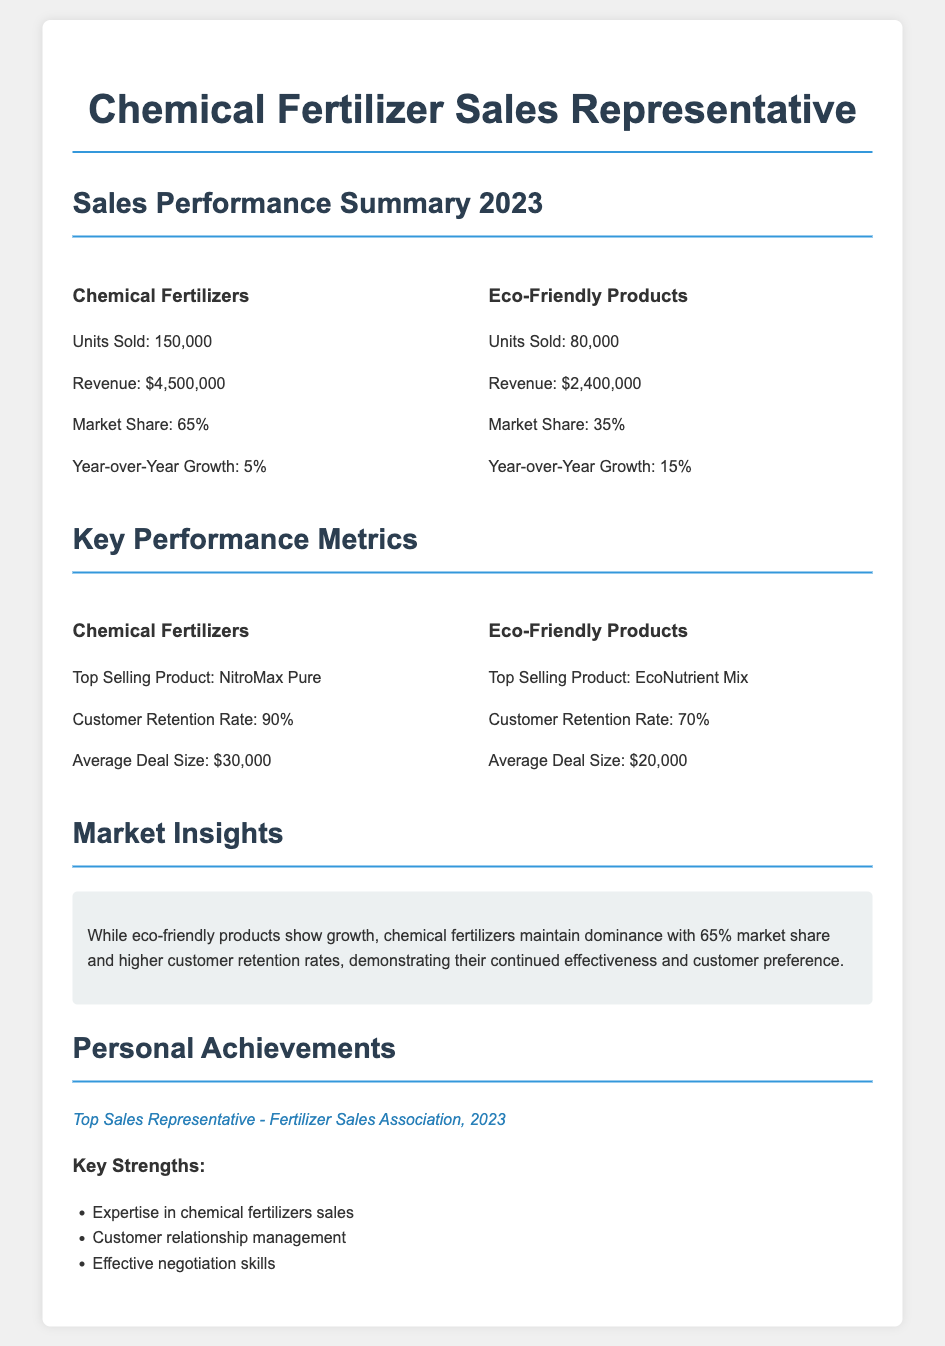what is the total revenue from chemical fertilizers? The total revenue from chemical fertilizers is specified in the document as $4,500,000.
Answer: $4,500,000 what is the market share of eco-friendly products? The market share of eco-friendly products is explicitly mentioned in the document as 35%.
Answer: 35% what is the year-over-year growth for chemical fertilizers? The document states that the year-over-year growth for chemical fertilizers is 5%.
Answer: 5% what is the top selling product in eco-friendly products? The top selling product in eco-friendly products is identified in the document as EcoNutrient Mix.
Answer: EcoNutrient Mix how many units of chemical fertilizers were sold? The number of units sold for chemical fertilizers is clearly listed in the document as 150,000.
Answer: 150,000 what does the customer retention rate for eco-friendly products indicate? The customer retention rate for eco-friendly products is provided in the document as 70%, indicating customer loyalty.
Answer: 70% which product had the highest average deal size? The document indicates that the top average deal size is linked to chemical fertilizers at $30,000.
Answer: $30,000 what recognition did the sales representative achieve in 2023? The document notes that the sales representative was awarded Top Sales Representative - Fertilizer Sales Association, 2023.
Answer: Top Sales Representative - Fertilizer Sales Association, 2023 how many units of eco-friendly products were sold? The units sold for eco-friendly products are mentioned in the document as 80,000.
Answer: 80,000 